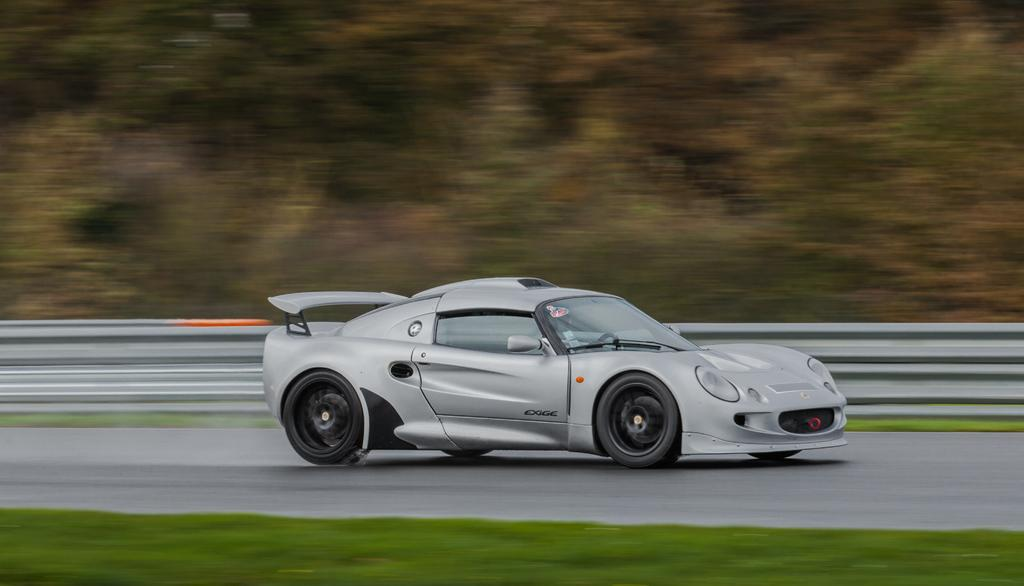What is the main subject of the image? The main subject of the image is a car. Where is the car located in the image? The car is on the road. What type of fog can be seen surrounding the car in the image? There is no fog present in the image; the car is on the road with no visible obstructions. What is the car saying good-bye to in the image? Cars do not have the ability to say good-bye, and there is no indication of any farewell in the image. 